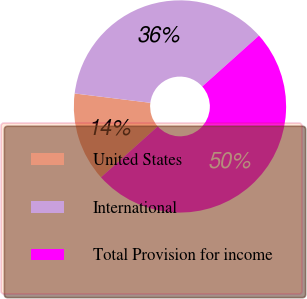Convert chart to OTSL. <chart><loc_0><loc_0><loc_500><loc_500><pie_chart><fcel>United States<fcel>International<fcel>Total Provision for income<nl><fcel>13.59%<fcel>36.41%<fcel>50.0%<nl></chart> 